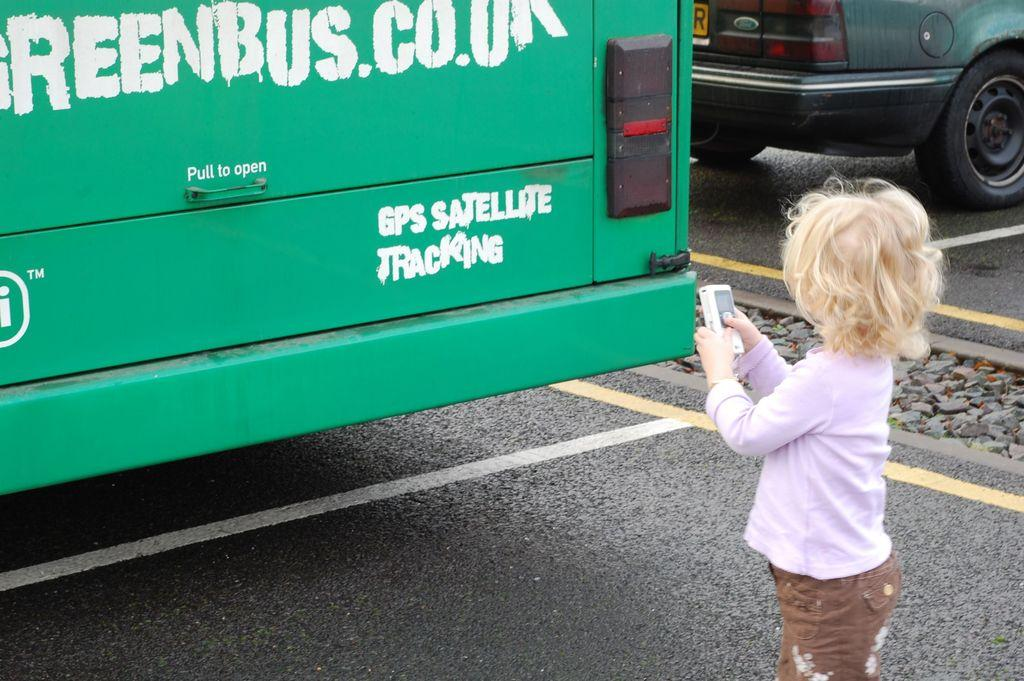What can be seen on the road in the image? There are vehicles on the road in the image. Who is present in the image besides the vehicles? There is a girl standing in the image. What is the girl holding in the image? The girl is holding a mobile in the image. Can you see a flock of birds flying over the vehicles in the image? There is no mention of birds or a flock in the image, so we cannot confirm their presence. 